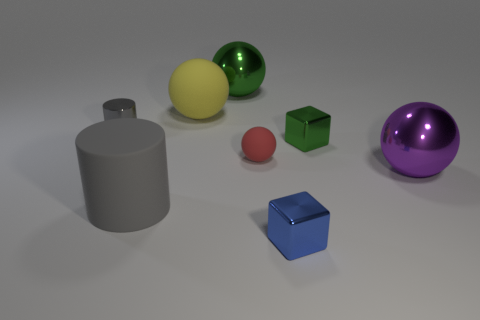Add 2 objects. How many objects exist? 10 Subtract all cylinders. How many objects are left? 6 Add 5 small spheres. How many small spheres are left? 6 Add 1 brown metallic objects. How many brown metallic objects exist? 1 Subtract 0 cyan blocks. How many objects are left? 8 Subtract all large green things. Subtract all green cubes. How many objects are left? 6 